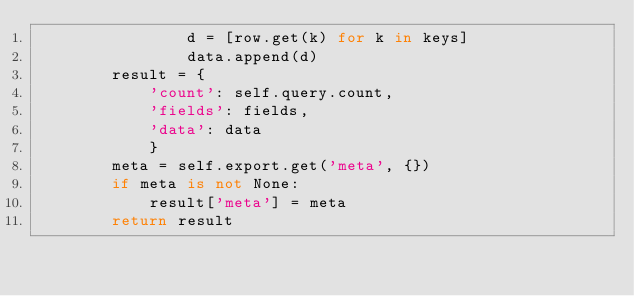Convert code to text. <code><loc_0><loc_0><loc_500><loc_500><_Python_>                d = [row.get(k) for k in keys]
                data.append(d)
        result = {
            'count': self.query.count,
            'fields': fields,
            'data': data
            }
        meta = self.export.get('meta', {})
        if meta is not None:
            result['meta'] = meta
        return result
</code> 